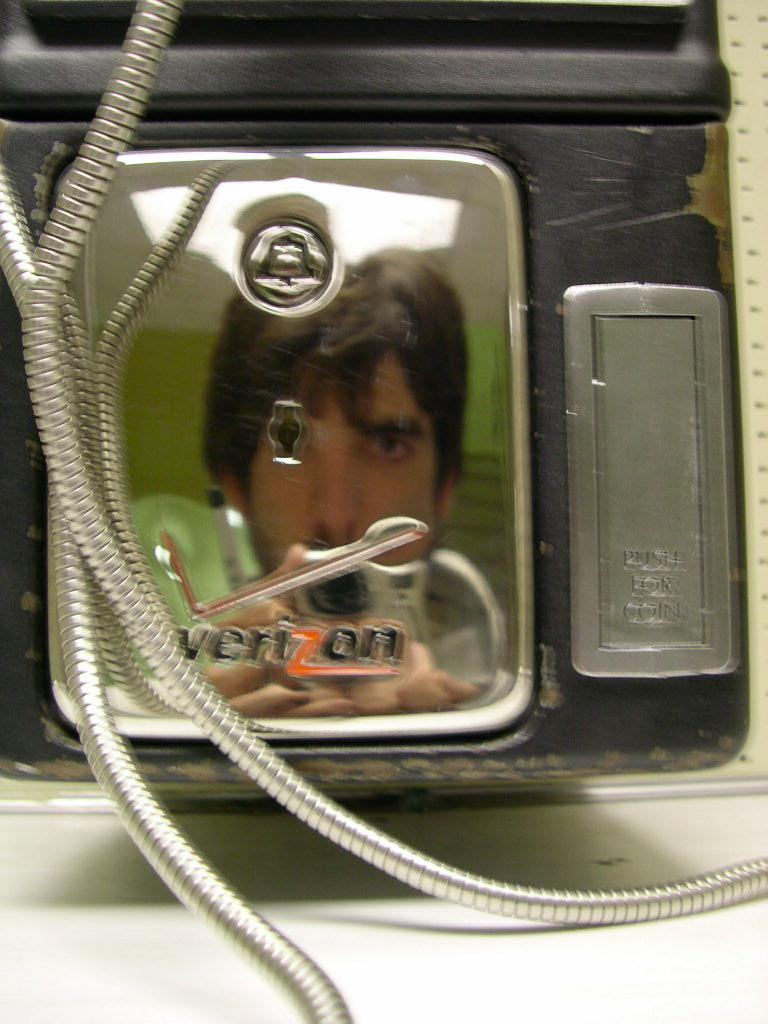What is the main subject of the image? There is an object in the image. Can you describe the object in the image? The object has a reflection of a person on it. What type of soda is being served in the image? There is no soda present in the image; it only features an object with a reflection of a person on it. What type of bun is being used to make a sandwich in the image? There is no sandwich or bun present in the image. 